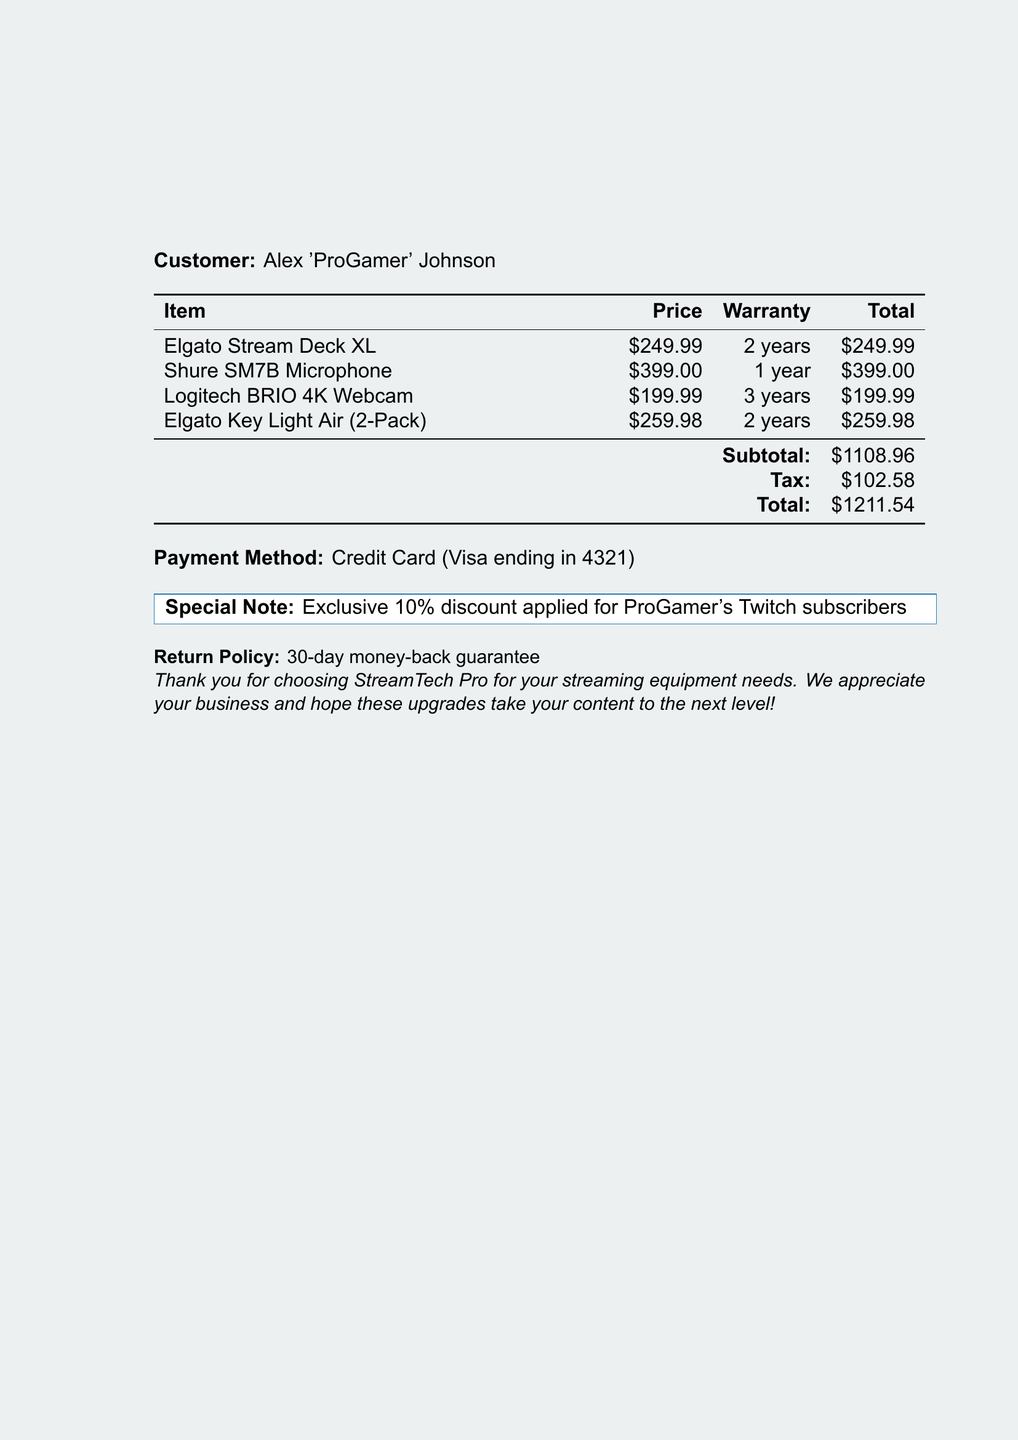What is the name of the customer? The customer listed on the receipt is Alex 'ProGamer' Johnson.
Answer: Alex 'ProGamer' Johnson What is the total amount after tax? The total amount after tax is calculated as subtotal plus tax, which is $1108.96 + $102.58.
Answer: $1211.54 How many years of warranty does the Logitech BRIO 4K Webcam have? The warranty duration for the Logitech BRIO 4K Webcam is mentioned in the document as 3 years.
Answer: 3 years What method was used for payment? The payment method specified in the document is through a credit card with Visa ending in 4321.
Answer: Credit Card (Visa ending in 4321) What is the subtotal before tax? The subtotal before tax, which is the sum of all listed item prices, is $1108.96.
Answer: $1108.96 What is the return policy period stated in the document? The document states a return policy of a 30-day money-back guarantee.
Answer: 30-day money-back guarantee How many items were purchased in total? The number of items listed in the bill is four.
Answer: Four What special discount was applied to this purchase? The receipt mentions that an exclusive 10% discount was applied for ProGamer's Twitch subscribers.
Answer: 10% discount 